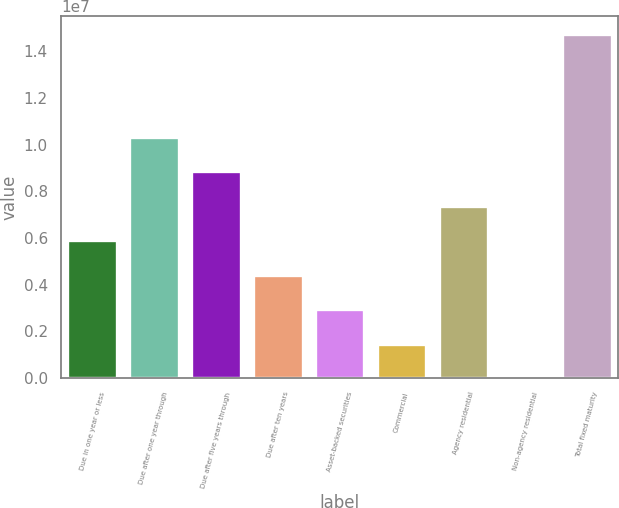Convert chart to OTSL. <chart><loc_0><loc_0><loc_500><loc_500><bar_chart><fcel>Due in one year or less<fcel>Due after one year through<fcel>Due after five years through<fcel>Due after ten years<fcel>Asset-backed securities<fcel>Commercial<fcel>Agency residential<fcel>Non-agency residential<fcel>Total fixed maturity<nl><fcel>5.90303e+06<fcel>1.03299e+07<fcel>8.8543e+06<fcel>4.4274e+06<fcel>2.95176e+06<fcel>1.47613e+06<fcel>7.37866e+06<fcel>494<fcel>1.47568e+07<nl></chart> 